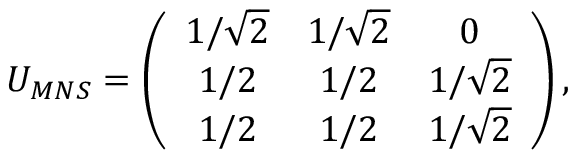Convert formula to latex. <formula><loc_0><loc_0><loc_500><loc_500>U _ { M N S } = \left ( \begin{array} { c c c } { { 1 / \sqrt { 2 } } } & { { 1 / \sqrt { 2 } } } & { 0 } \\ { 1 / 2 } & { 1 / 2 } & { { 1 / \sqrt { 2 } } } \\ { 1 / 2 } & { 1 / 2 } & { { 1 / \sqrt { 2 } } } \end{array} \right ) ,</formula> 